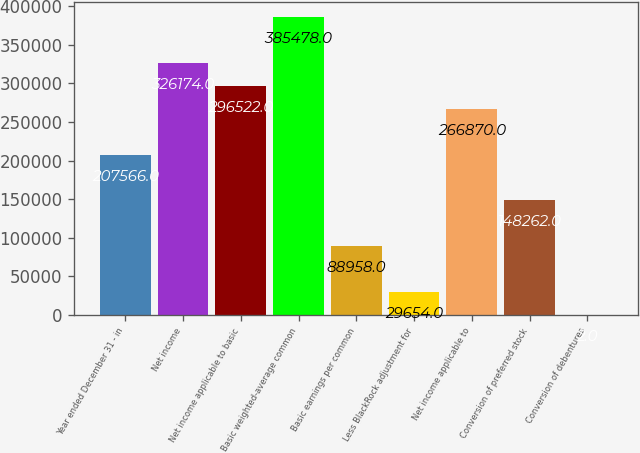<chart> <loc_0><loc_0><loc_500><loc_500><bar_chart><fcel>Year ended December 31 - in<fcel>Net income<fcel>Net income applicable to basic<fcel>Basic weighted-average common<fcel>Basic earnings per common<fcel>Less BlackRock adjustment for<fcel>Net income applicable to<fcel>Conversion of preferred stock<fcel>Conversion of debentures<nl><fcel>207566<fcel>326174<fcel>296522<fcel>385478<fcel>88958<fcel>29654<fcel>266870<fcel>148262<fcel>2<nl></chart> 